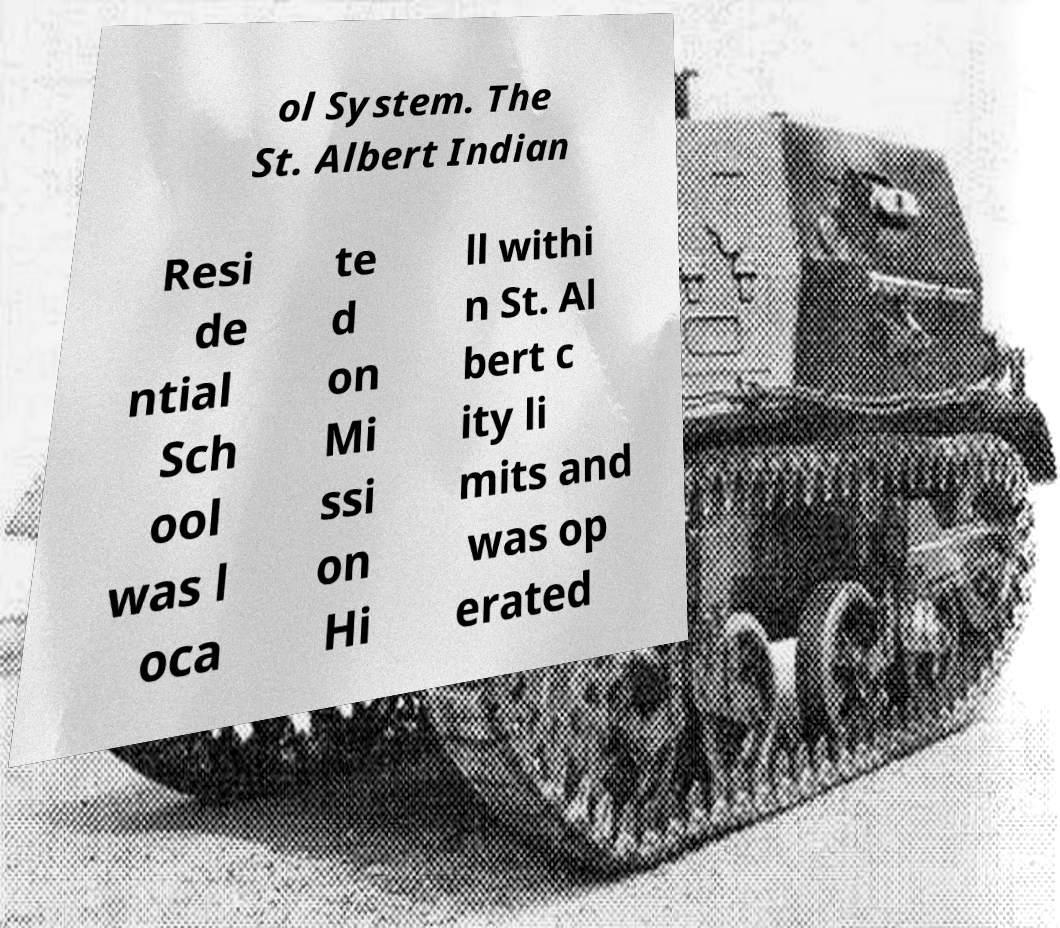Please read and relay the text visible in this image. What does it say? ol System. The St. Albert Indian Resi de ntial Sch ool was l oca te d on Mi ssi on Hi ll withi n St. Al bert c ity li mits and was op erated 